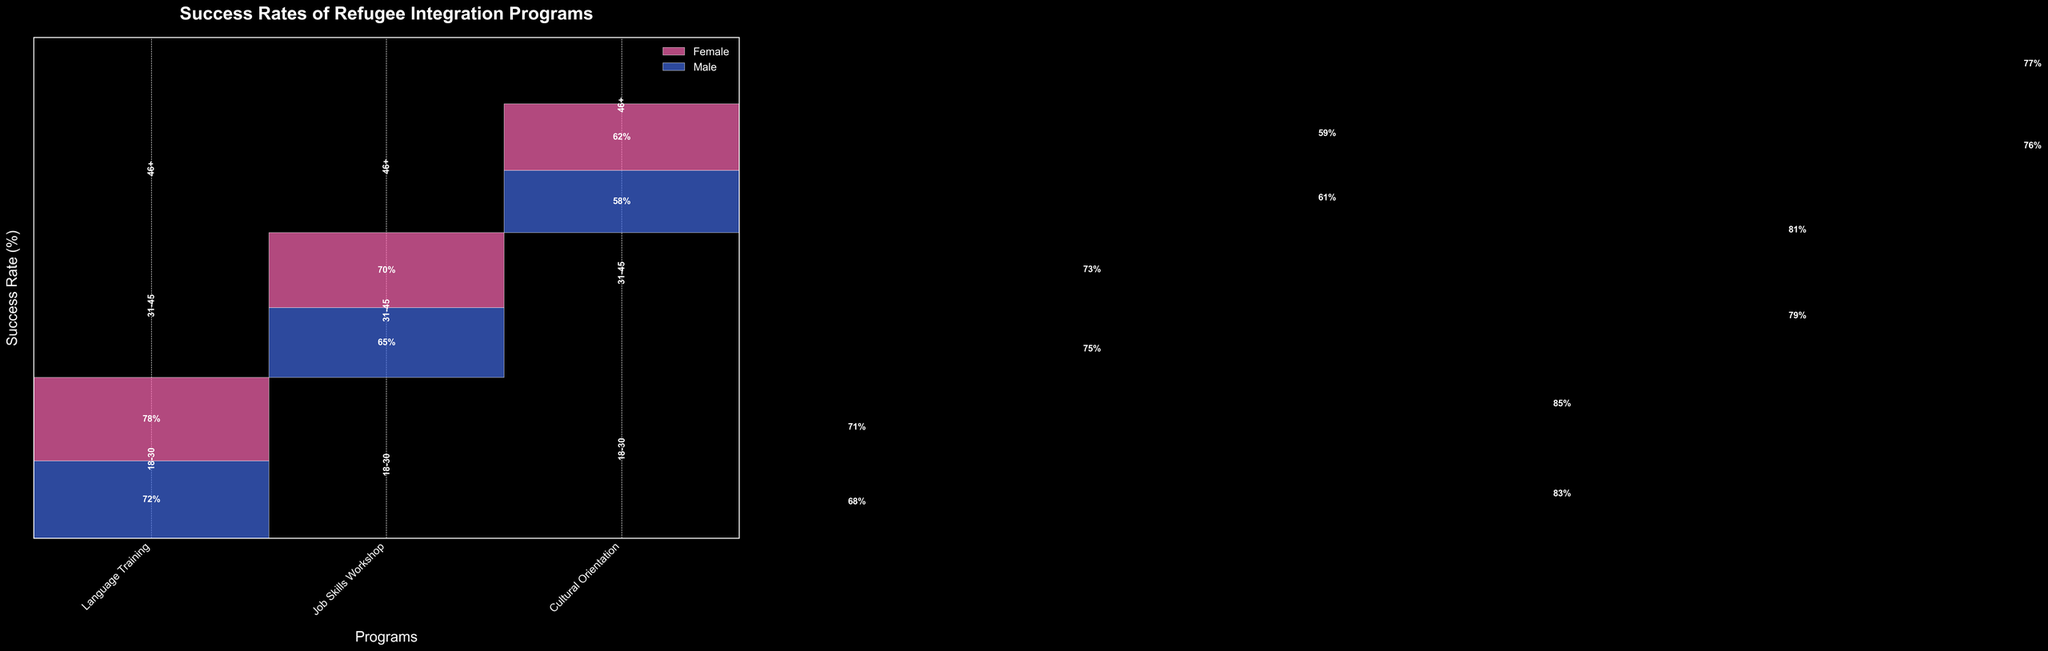What is the title of the plot? The title is usually found at the top center of the plot. Here, it clearly states the purpose of the visualization.
Answer: Success Rates of Refugee Integration Programs What are the three programs displayed on the plot? These are the labels on the x-axis representing different refugee integration programs. They can be read directly from the x-axis ticks.
Answer: Language Training, Job Skills Workshop, Cultural Orientation Which age group had the highest success rate in the Language Training program? By comparing the success rates for different age groups within the Language Training program, the highest rate can be identified.
Answer: 18-30 What is the success rate of females in the 18-30 age group for the Cultural Orientation program? Locate the section for the 18-30 age group in the Cultural Orientation column and identify the success rate color-coded for females (usually pink).
Answer: 85% Did males or females have a higher success rate in the Job Skills Workshop for ages 31-45? Compare the success rates for males and females within the 31-45 age group for the Job Skills Workshop. Look at the height of the respective bars.
Answer: Males What is the difference in success rate between males and females in the 46+ age group for Language Training? Identify the success rate for males and females in the 46+ age group under Language Training and calculate the difference.
Answer: 4% Which gender had a higher overall success rate for the Cultural Orientation program across all age groups? Sum up the success rates for males and females in the Cultural Orientation program across all age groups and compare.
Answer: Female What is the average success rate for the Job Skills Workshop across all age groups? Add up the success rates for each age group in the Job Skills Workshop and divide by the number of age groups.
Answer: Approx. 68 How does the success rate for females in the 31-45 age group compare between Language Training and Cultural Orientation? Compare the success rates for females in the 31-45 age group for both programs by checking the respective heights of the bars.
Answer: Higher in Cultural Orientation What is the combined success rate for males in all programs within the 18-30 age group? Add the success rates of males in the 18-30 age group across all three programs.
Answer: 223% 